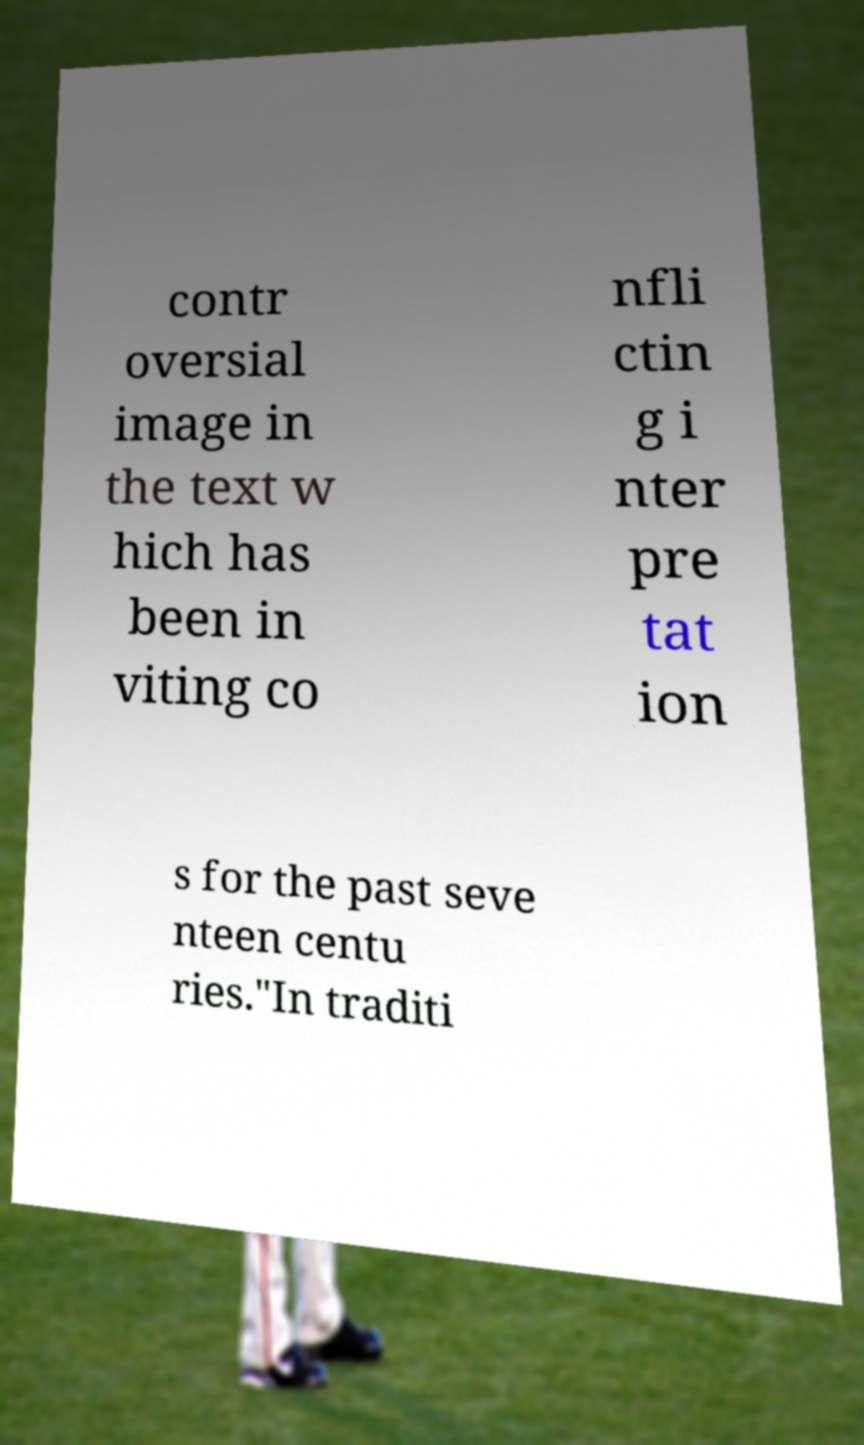Could you extract and type out the text from this image? contr oversial image in the text w hich has been in viting co nfli ctin g i nter pre tat ion s for the past seve nteen centu ries."In traditi 